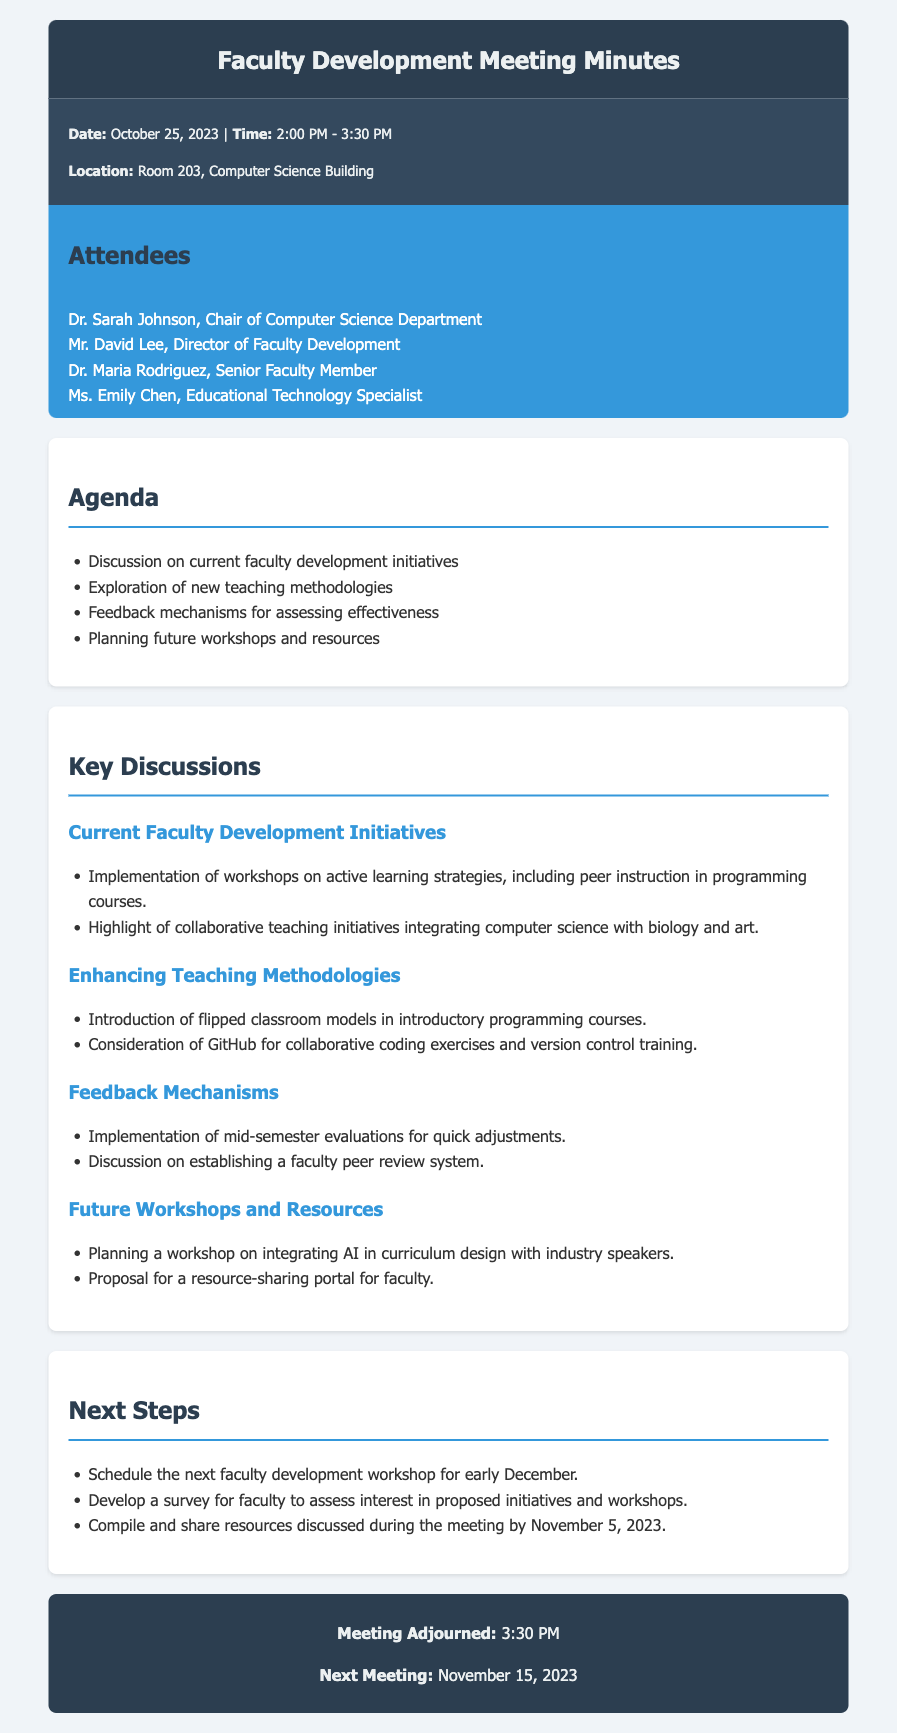What is the date of the meeting? The date is explicitly stated in the meeting minutes.
Answer: October 25, 2023 Who is the Chair of the Computer Science Department? The minutes list the attendees and their roles, identifying the chair.
Answer: Dr. Sarah Johnson What are the topics included in the agenda? The agenda outlines the key discussion points and topics for the meeting.
Answer: Discussion on current faculty development initiatives What is one teaching methodology discussed for enhancing teaching? The discussions highlight new methodologies being considered.
Answer: Flipped classroom models What is one feedback mechanism mentioned for assessing effectiveness? The document details the feedback mechanisms discussed during the meeting.
Answer: Mid-semester evaluations When is the next meeting scheduled? The time for the next meeting is given before the adjournment section.
Answer: November 15, 2023 What is one proposed resource for faculty mentioned in the minutes? The document includes suggestions for future resources and workshops.
Answer: Resource-sharing portal How long did the meeting last? The start and end times specified in the meeting info detail the meeting duration.
Answer: 1 hour 30 minutes What is one initiative from the current faculty development initiatives? The minutes describe specific initiatives that have been implemented.
Answer: Workshops on active learning strategies 